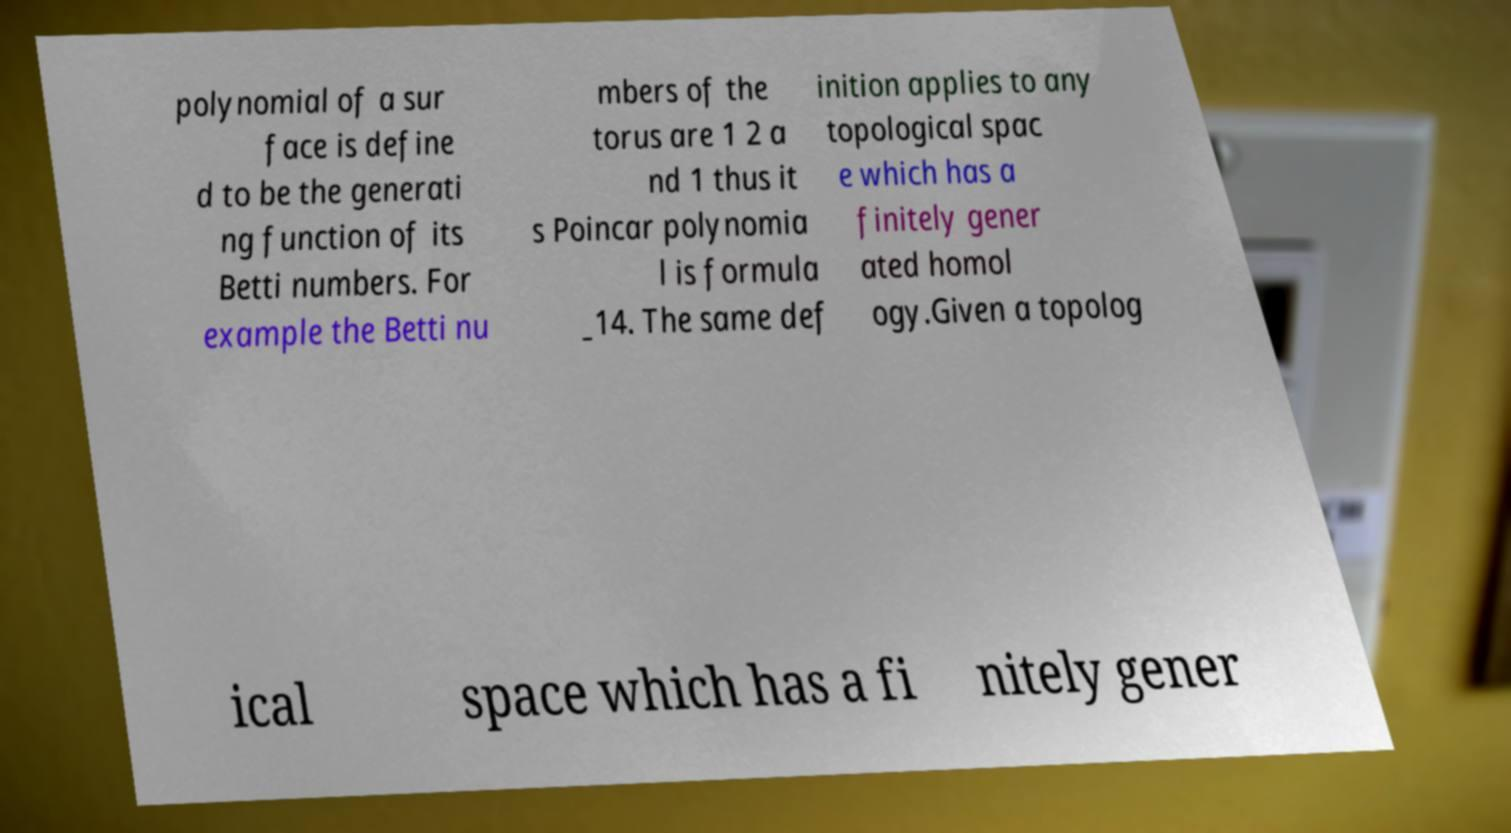There's text embedded in this image that I need extracted. Can you transcribe it verbatim? polynomial of a sur face is define d to be the generati ng function of its Betti numbers. For example the Betti nu mbers of the torus are 1 2 a nd 1 thus it s Poincar polynomia l is formula _14. The same def inition applies to any topological spac e which has a finitely gener ated homol ogy.Given a topolog ical space which has a fi nitely gener 